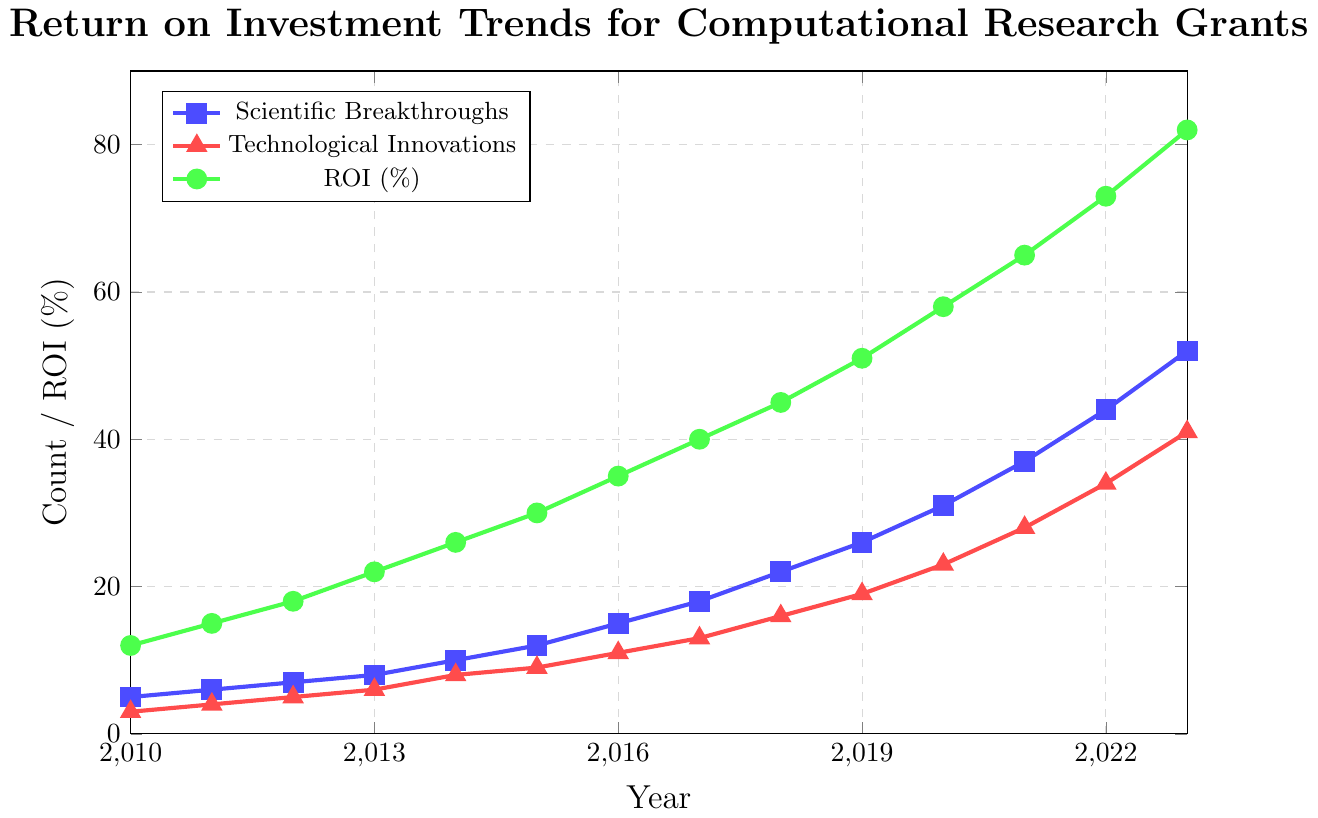What trend can you observe in the ROI (\%) over the period from 2010 to 2023? The ROI (\%) shows a consistently upward trend, increasing from around 12\% in 2010 to approximately 82\% in 2023. This suggests that the return on investment for computational research grants has been growing steadily over the years.
Answer: Upward trend Which year had the most significant increase in Scientific Breakthroughs compared to the previous year? To identify the year with the most significant increase, calculate the year-over-year difference in Scientific Breakthroughs. The biggest increase is between 2016 and 2017, rising from 15 to 18 breakthroughs, a difference of 3.
Answer: 2017 In which year does Technological Innovations first exceed 20? By examining the values for Technological Innovations, the count first exceeds 20 in the year 2018. Before that, the count is lower than 20 in all years seen on the chart.
Answer: 2018 Compare the counts of Scientific Breakthroughs and Technological Innovations in 2021. Which is higher and by how much? In 2021, the count of Scientific Breakthroughs is 37, and Technological Innovations is 28. The Scientific Breakthroughs are higher by 37 - 28 = 9.
Answer: Scientific Breakthroughs by 9 What is the average ROI (\%) in the years 2015, 2016, and 2017? Sum the ROI (\%) for the years 2015 (30), 2016 (35), and 2017 (40), then divide by 3. The sum is 30 + 35 + 40 = 105, so the average is 105 / 3 = 35\%.
Answer: 35\% Which year shows the most balanced growth between Scientific Breakthroughs and Technological Innovations? A year with similar increases in both metrics can be considered balanced. Checking differences between consecutive years, 2015 to 2016 shows a 3-unit increase for both Scientific Breakthroughs (12 to 15) and Technological Innovations (9 to 11).
Answer: 2016 What is the difference in ROI (\%) between 2023 and 2010? ROI(\%) in 2023 is 82 and in 2010 is 12. The difference is 82 - 12 = 70.
Answer: 70 How much did the Scientific Breakthroughs increase from the start to the end of the period? Scientific Breakthroughs in 2023 are 52 and in 2010 are 5. The increase is 52 - 5 = 47.
Answer: 47 Which color represents Technological Innovations on the chart? The chart uses different colors to represent different datasets. Technological Innovations are represented by a red line with triangle markers.
Answer: Red What was the ROI (\%) in 2019, and how does it compare with that of 2022? ROI (\%) in 2019 is 51, and in 2022 is 73. The ROI increased by 73 - 51 = 22\% over these years.
Answer: 22\% 